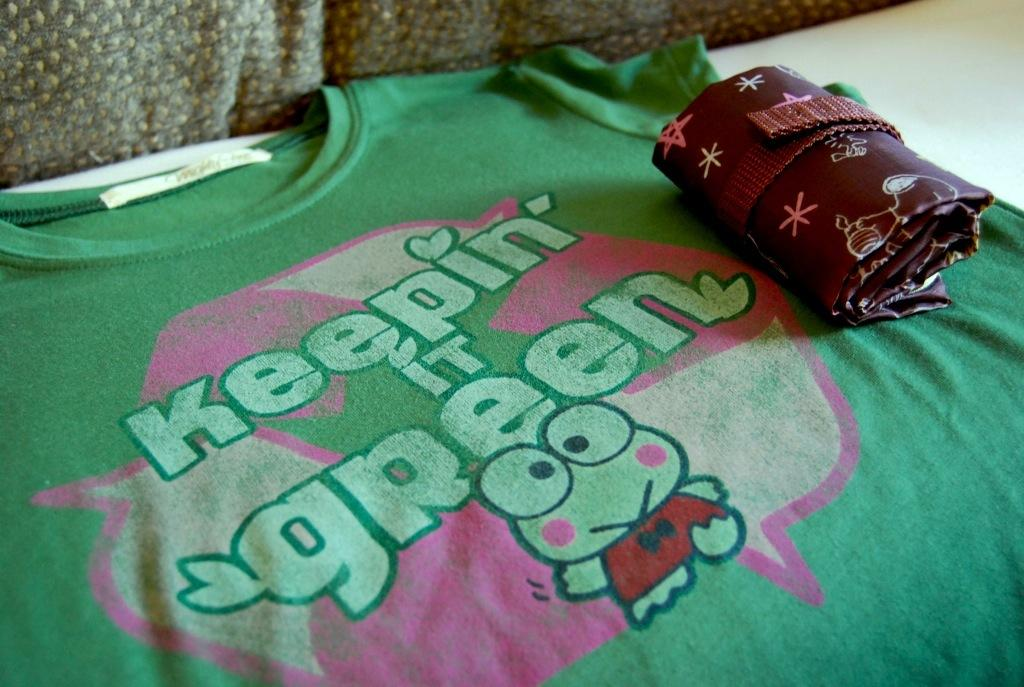What color is the T-shirt in the image? The T-shirt in the image is green. What is on the T-shirt? The T-shirt has text on it. What can be seen on the white surface in the image? There are brown objects on the white surface in the image. What type of winter activity is being performed in the image? There is no indication of any winter activity in the image; it features a green T-shirt with text and brown objects on a white surface. 